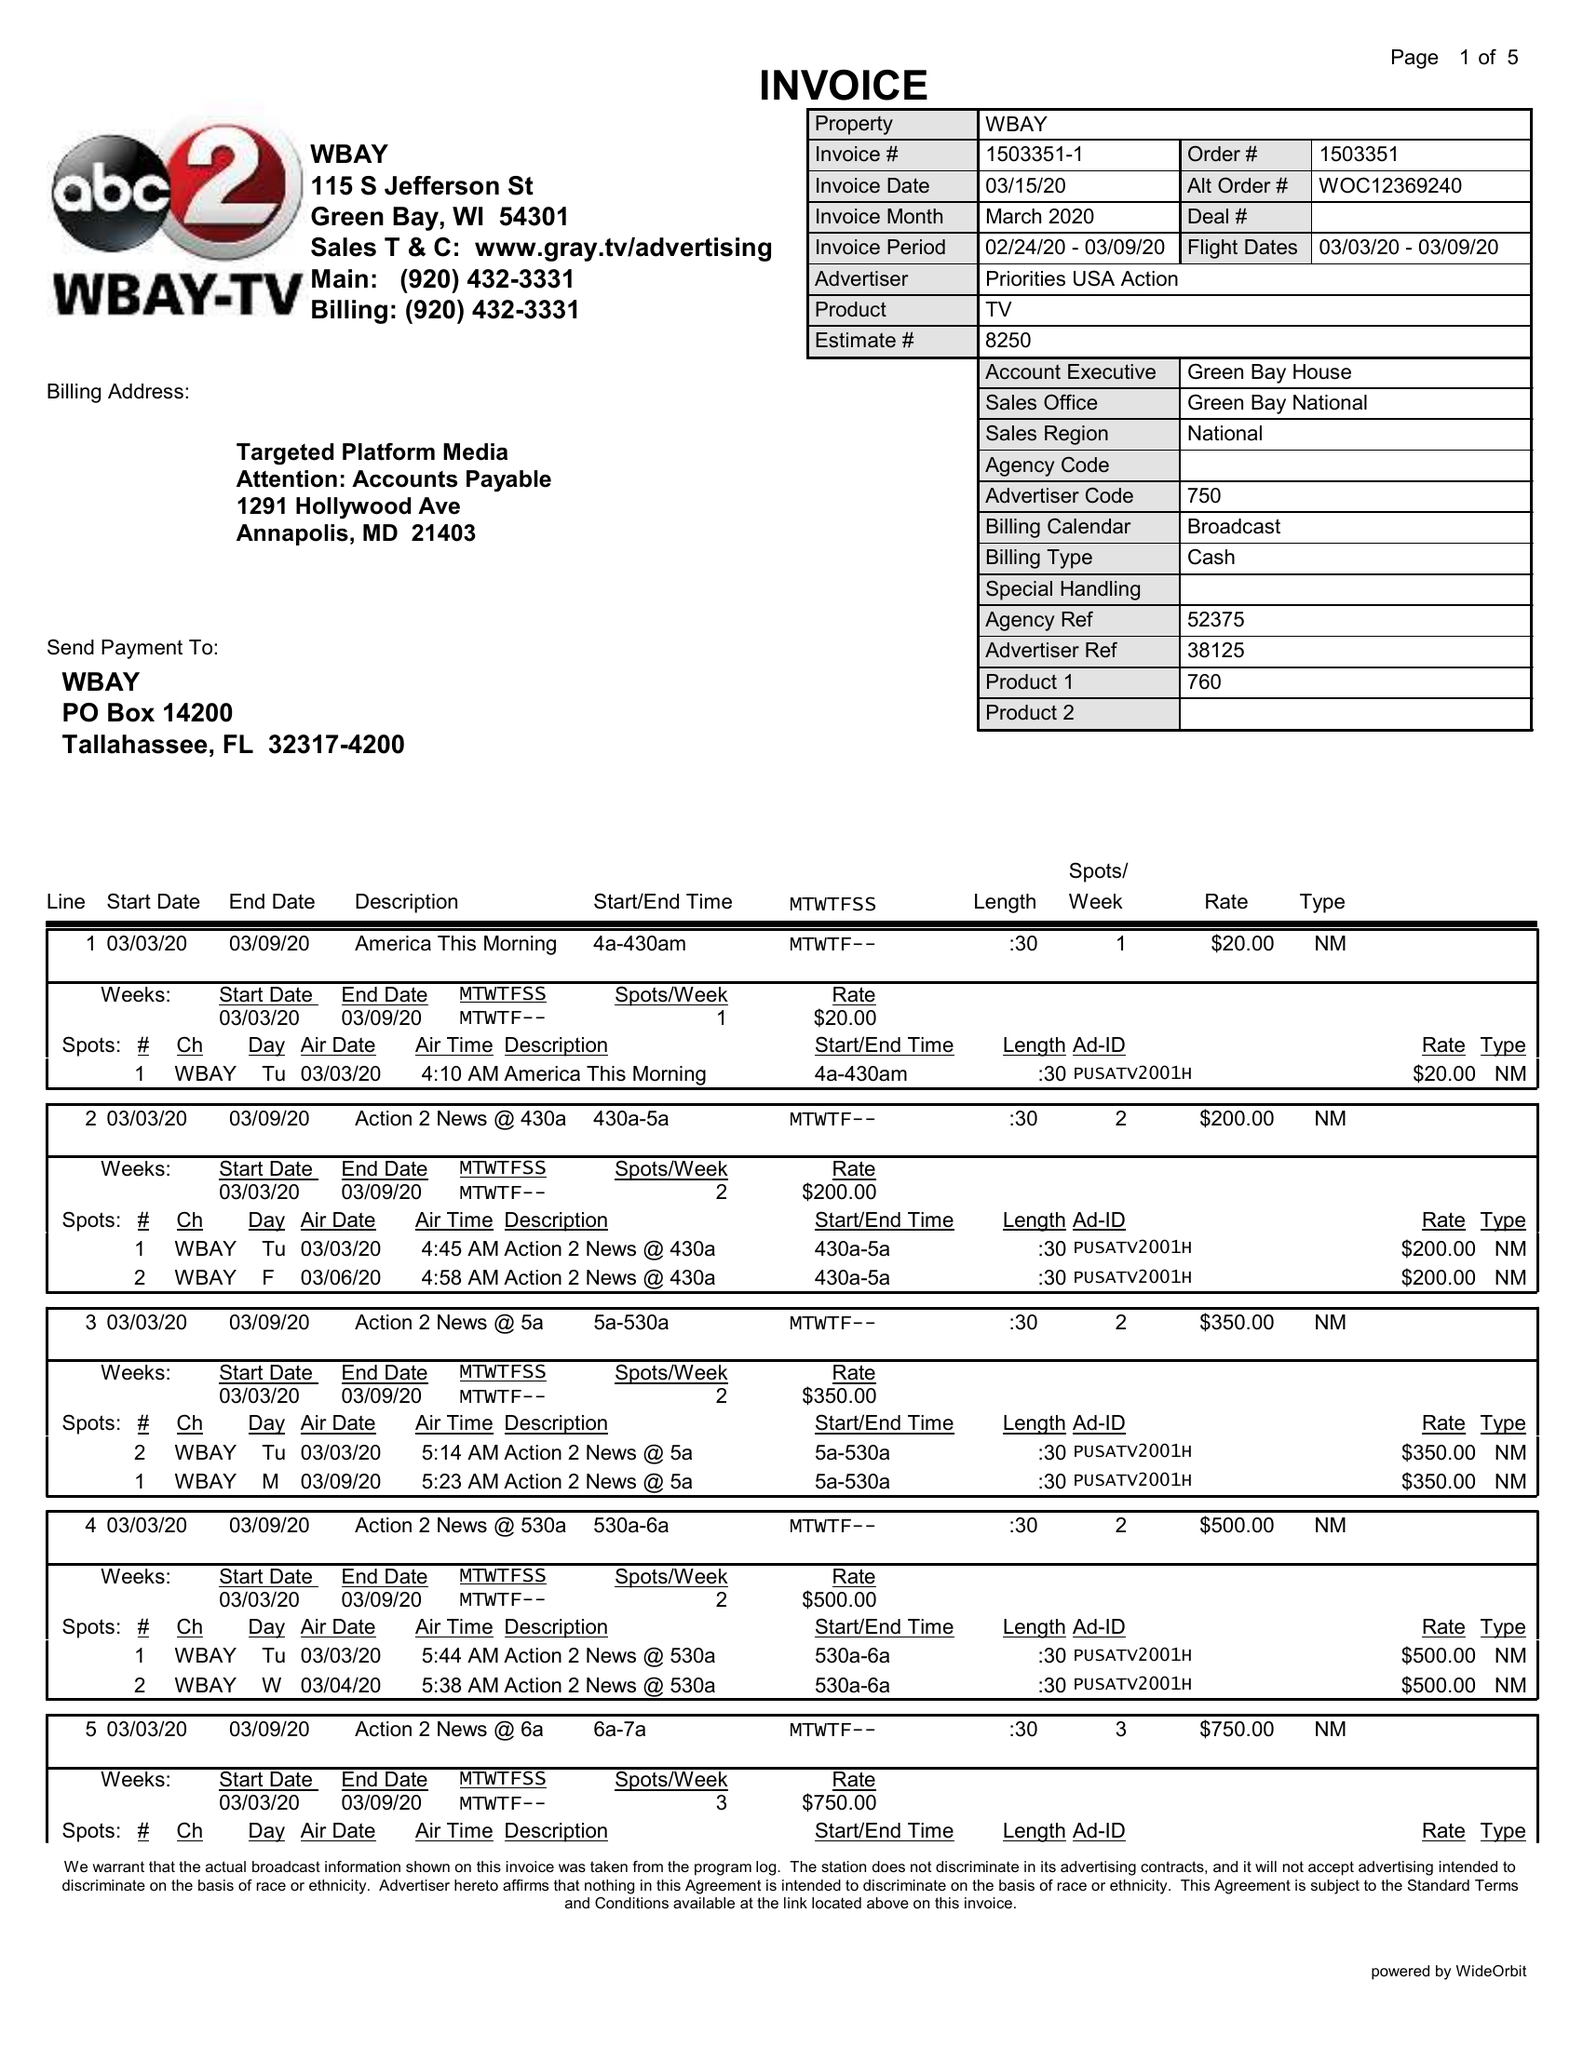What is the value for the flight_from?
Answer the question using a single word or phrase. 03/03/20 